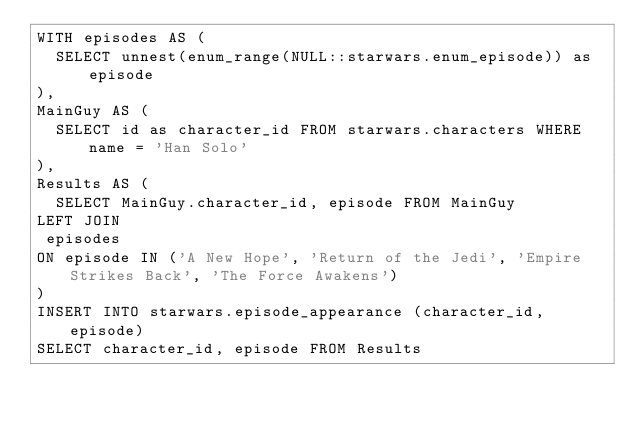<code> <loc_0><loc_0><loc_500><loc_500><_SQL_>WITH episodes AS (
  SELECT unnest(enum_range(NULL::starwars.enum_episode)) as episode
),
MainGuy AS (
  SELECT id as character_id FROM starwars.characters WHERE name = 'Han Solo'
),
Results AS (
  SELECT MainGuy.character_id, episode FROM MainGuy
LEFT JOIN
 episodes 
ON episode IN ('A New Hope', 'Return of the Jedi', 'Empire Strikes Back', 'The Force Awakens')
)
INSERT INTO starwars.episode_appearance (character_id, episode)
SELECT character_id, episode FROM Results
</code> 